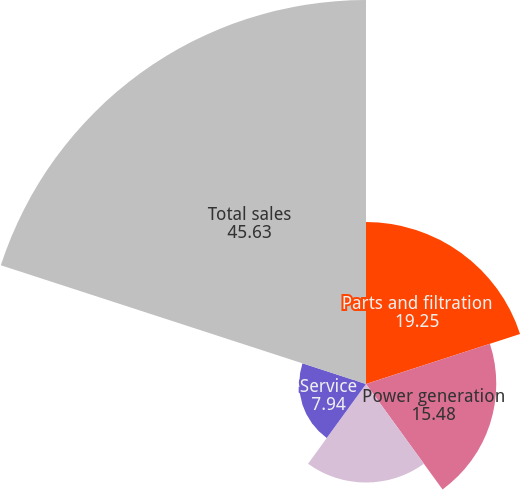Convert chart. <chart><loc_0><loc_0><loc_500><loc_500><pie_chart><fcel>Parts and filtration<fcel>Power generation<fcel>Engines<fcel>Service<fcel>Total sales<nl><fcel>19.25%<fcel>15.48%<fcel>11.71%<fcel>7.94%<fcel>45.63%<nl></chart> 